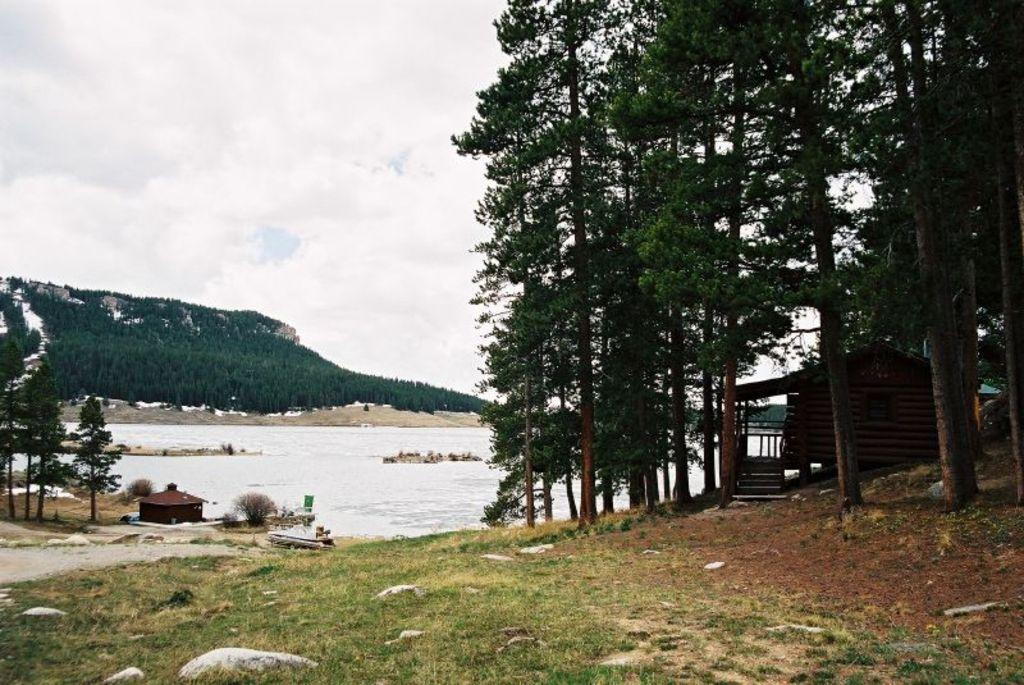What natural element can be seen in the image? Water is visible in the image. What geographical feature is present in the image? There are mountains in the image. What type of vegetation can be seen in the image? Trees and grass are visible in the image. What type of human-made structures are present in the image? There are houses in the image. What part of the natural environment is visible in the image? The sky is visible in the image. What type of statement can be seen written on the mountains in the image? There are no statements written on the mountains in the image; they are natural geographical features. 